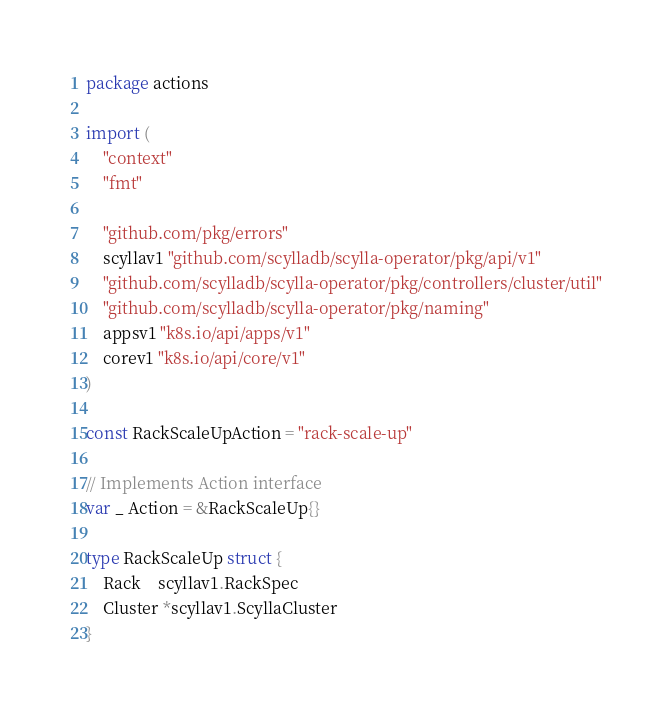<code> <loc_0><loc_0><loc_500><loc_500><_Go_>package actions

import (
	"context"
	"fmt"

	"github.com/pkg/errors"
	scyllav1 "github.com/scylladb/scylla-operator/pkg/api/v1"
	"github.com/scylladb/scylla-operator/pkg/controllers/cluster/util"
	"github.com/scylladb/scylla-operator/pkg/naming"
	appsv1 "k8s.io/api/apps/v1"
	corev1 "k8s.io/api/core/v1"
)

const RackScaleUpAction = "rack-scale-up"

// Implements Action interface
var _ Action = &RackScaleUp{}

type RackScaleUp struct {
	Rack    scyllav1.RackSpec
	Cluster *scyllav1.ScyllaCluster
}
</code> 